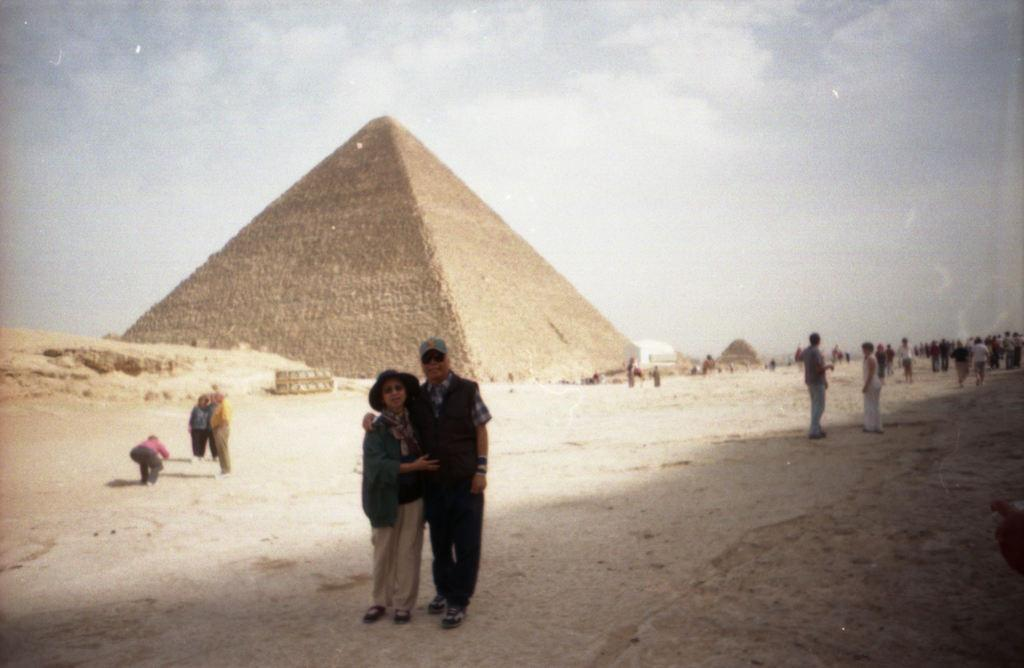How many people are in the image? There is a group of people in the image. What is the position of the people in the image? The people are standing on the ground. What can be seen in the background of the image? There is a pyramid and the sky visible in the background of the image. What other objects can be seen in the background of the image? There are other objects present in the background of the image. What type of beast is interacting with the people in the image? There is no beast present in the image; it features a group of people standing on the ground with a pyramid and other objects in the background. What kind of pickle is being used as a prop in the image? There is no pickle present in the image. 